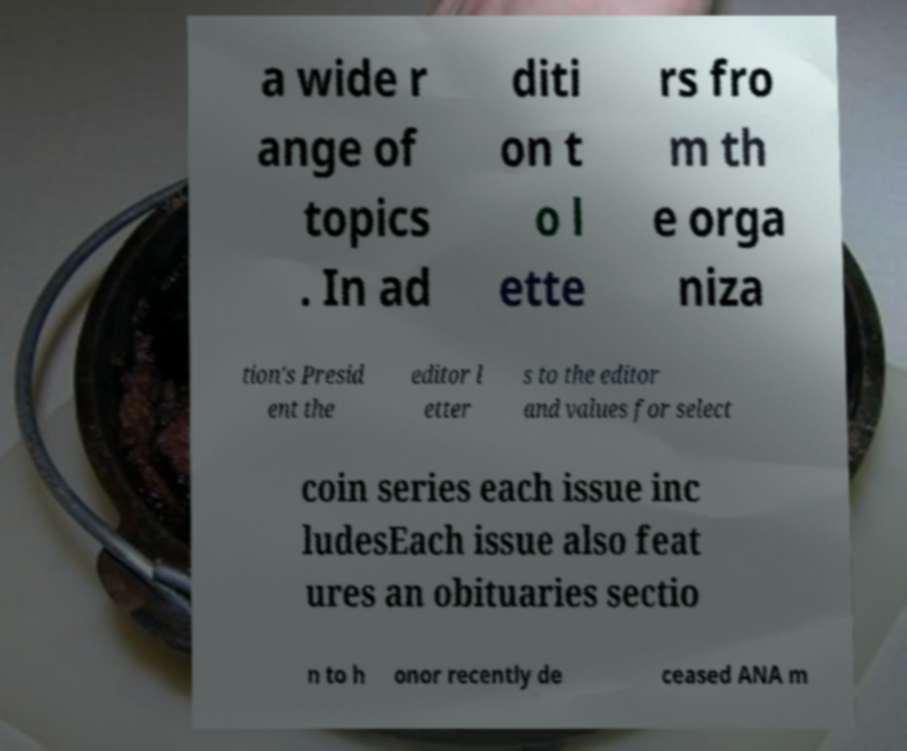Please identify and transcribe the text found in this image. a wide r ange of topics . In ad diti on t o l ette rs fro m th e orga niza tion's Presid ent the editor l etter s to the editor and values for select coin series each issue inc ludesEach issue also feat ures an obituaries sectio n to h onor recently de ceased ANA m 